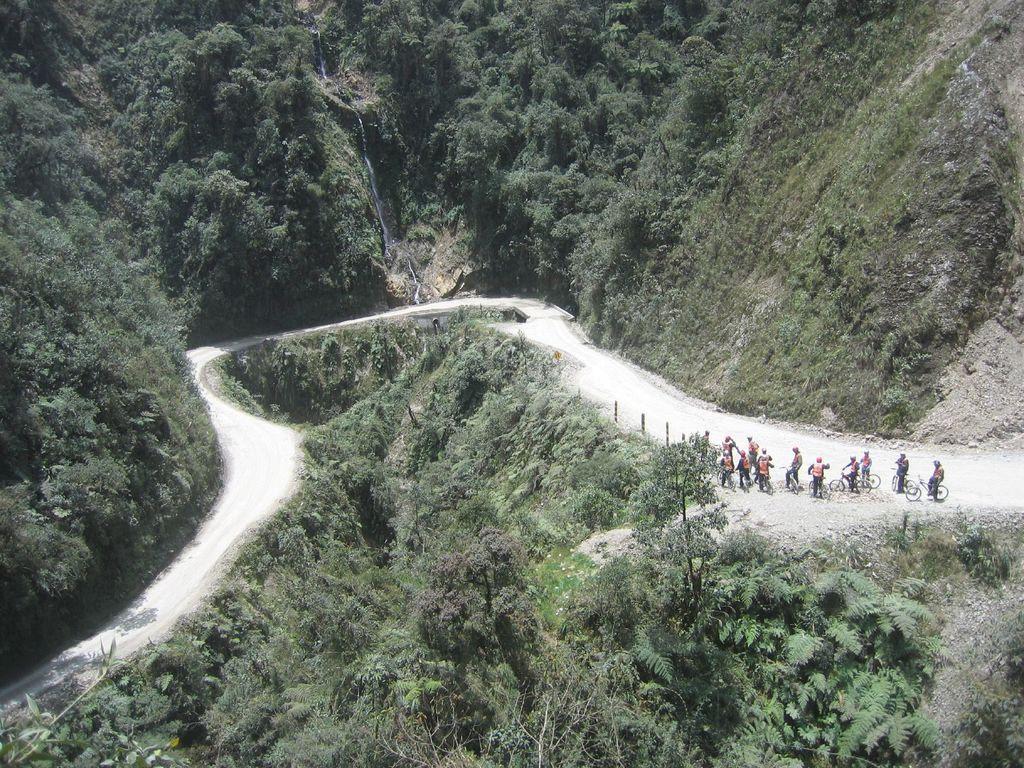Describe this image in one or two sentences. In the picture I can see some group of persons wearing helmets riding bicycle, there is road, there are some trees on mountain. 